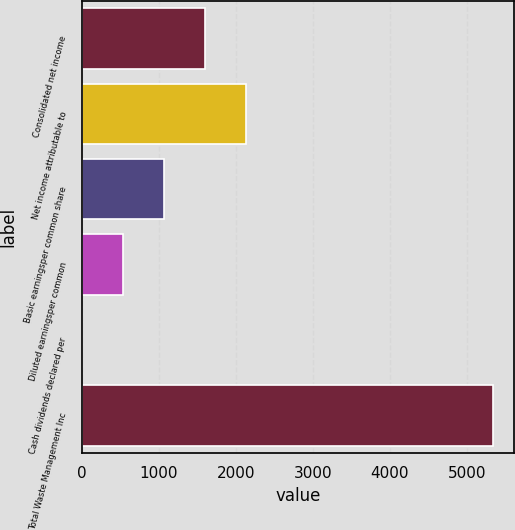Convert chart to OTSL. <chart><loc_0><loc_0><loc_500><loc_500><bar_chart><fcel>Consolidated net income<fcel>Net income attributable to<fcel>Basic earningsper common share<fcel>Diluted earningsper common<fcel>Cash dividends declared per<fcel>Total Waste Management Inc<nl><fcel>1604.59<fcel>2138.94<fcel>1070.24<fcel>535.89<fcel>1.54<fcel>5345<nl></chart> 